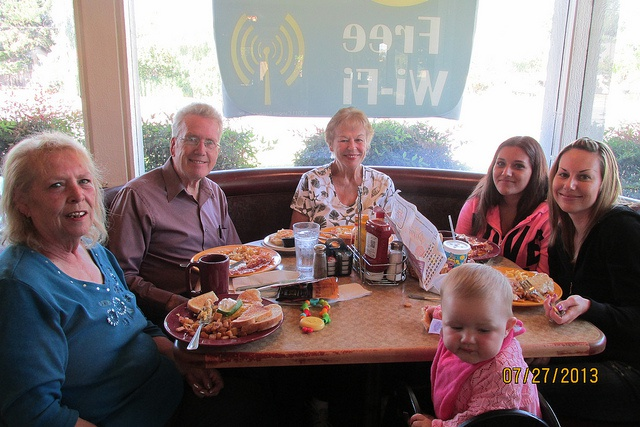Describe the objects in this image and their specific colors. I can see people in lavender, black, maroon, darkblue, and blue tones, dining table in lavender, brown, maroon, black, and darkgray tones, people in lavender, black, brown, and maroon tones, people in lavender, black, brown, and maroon tones, and people in lavender, maroon, brown, and darkgray tones in this image. 